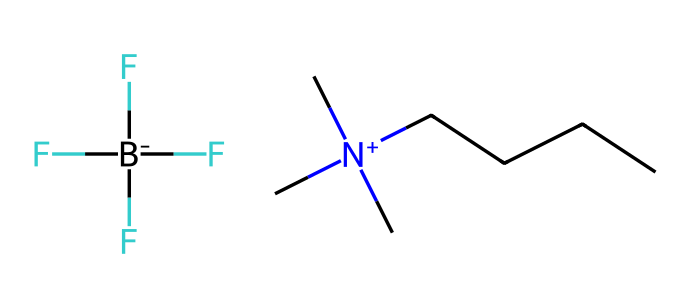What is the overall charge of this ionic liquid? The chemical structure reveals a quaternary ammonium cation (C[N+](C)(C)CCCC) and a perfluoroalkyl borate anion (F[B-](F)(F)F). The cation carries a positive charge, and the anion carries a negative charge, thus the overall charge is neutral.
Answer: neutral How many carbon atoms are present in the cation portion? The cation is represented by C[N+](C)(C)CCCC, which includes three carbon atoms from the (C)(C) groups and five from "CCCC", totaling to eight carbon atoms in the cation.
Answer: 8 What type of anion is present in this ionic liquid? The structure shows a boron atom bonded to fluorine atoms. The presence of F[B-](F)(F)F indicates that it's a fluorinated borate anion. Thus, it's a perfluoroalkyl borate.
Answer: perfluoroalkyl borate What is the significance of the quaternary ammonium structure in ionic liquids? Quaternary ammonium cations are often used in ionic liquids because they confer desirable properties such as low volatility and high thermal stability, which are crucial for processes like electroplating.
Answer: desirable properties What type of interactions primarily govern the behavior of this ionic liquid? The ionic liquid's behavior is primarily governed by ion-dipole and van der Waals interactions between the cation and anion, reflecting its ionic nature.
Answer: ion-dipole and van der Waals How might the fluorination of the anion affect the properties of the ionic liquid? Fluorination typically increases the hydrophobicity and thermal stability of the ionic liquid due to the strong C-F bonds, thus altering its solubility and stability in electroplating processes.
Answer: increases hydrophobicity and stability 